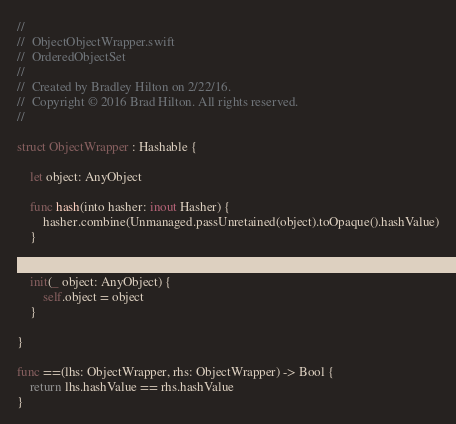Convert code to text. <code><loc_0><loc_0><loc_500><loc_500><_Swift_>//
//  ObjectObjectWrapper.swift
//  OrderedObjectSet
//
//  Created by Bradley Hilton on 2/22/16.
//  Copyright © 2016 Brad Hilton. All rights reserved.
//

struct ObjectWrapper : Hashable {
    
    let object: AnyObject
    
    func hash(into hasher: inout Hasher) {
        hasher.combine(Unmanaged.passUnretained(object).toOpaque().hashValue)
    }

    
    init(_ object: AnyObject) {
        self.object = object
    }
    
}

func ==(lhs: ObjectWrapper, rhs: ObjectWrapper) -> Bool {
    return lhs.hashValue == rhs.hashValue
}
</code> 